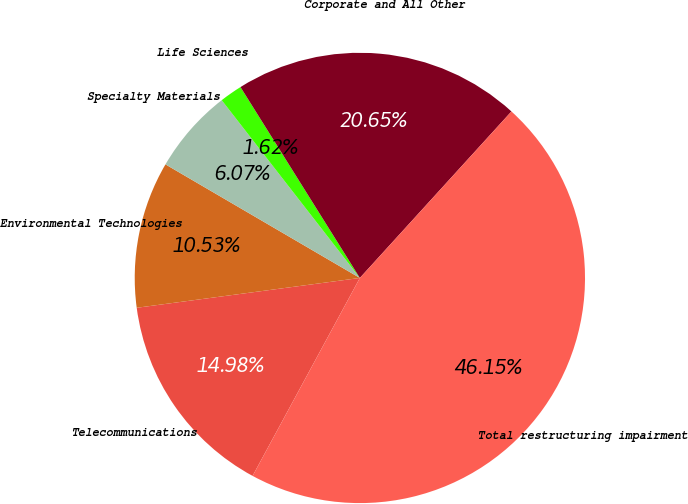Convert chart to OTSL. <chart><loc_0><loc_0><loc_500><loc_500><pie_chart><fcel>Telecommunications<fcel>Environmental Technologies<fcel>Specialty Materials<fcel>Life Sciences<fcel>Corporate and All Other<fcel>Total restructuring impairment<nl><fcel>14.98%<fcel>10.53%<fcel>6.07%<fcel>1.62%<fcel>20.65%<fcel>46.15%<nl></chart> 